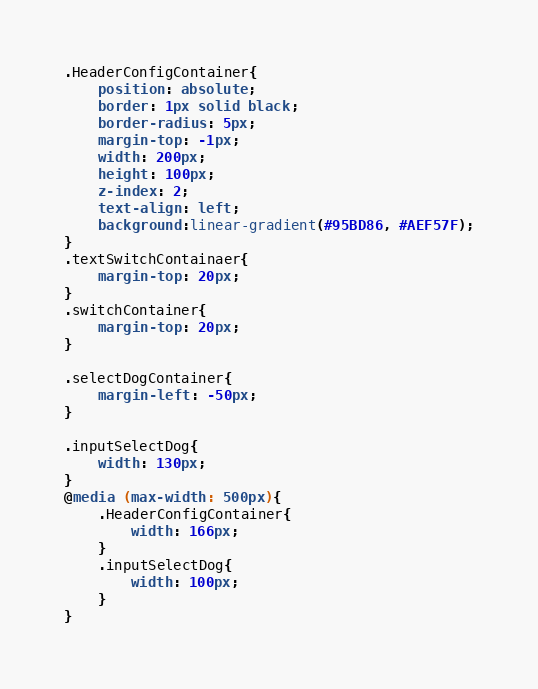<code> <loc_0><loc_0><loc_500><loc_500><_CSS_>
.HeaderConfigContainer{
	position: absolute;
	border: 1px solid black;
	border-radius: 5px;
	margin-top: -1px;
	width: 200px;
	height: 100px;
	z-index: 2;
	text-align: left;
	background:linear-gradient(#95BD86, #AEF57F);
}
.textSwitchContainaer{
	margin-top: 20px;
}
.switchContainer{
	margin-top: 20px;
}

.selectDogContainer{
	margin-left: -50px;
}

.inputSelectDog{
	width: 130px;
}
@media (max-width: 500px){
	.HeaderConfigContainer{
		width: 166px;
	}
	.inputSelectDog{
		width: 100px;
	}
}</code> 